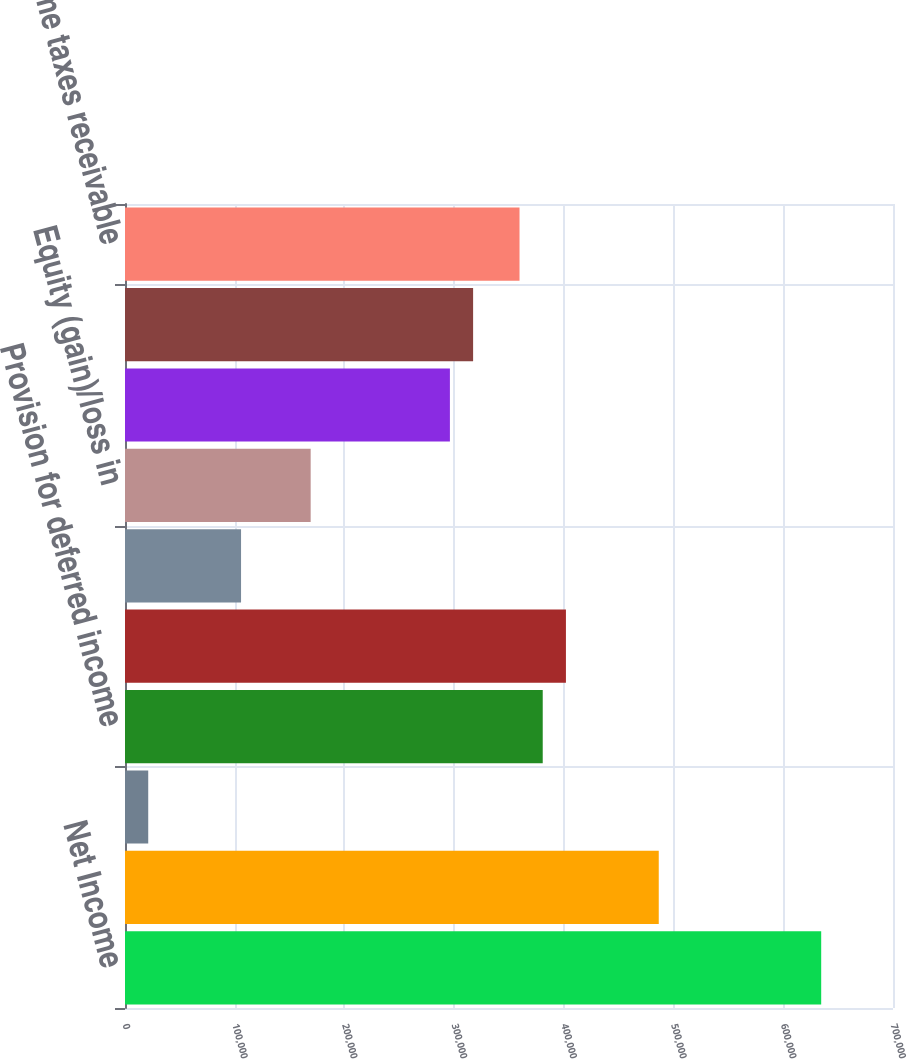Convert chart. <chart><loc_0><loc_0><loc_500><loc_500><bar_chart><fcel>Net Income<fcel>Depreciation and amortization<fcel>Other amortization<fcel>Provision for deferred income<fcel>Stock-based compensation<fcel>Loss on disposition of<fcel>Equity (gain)/loss in<fcel>Accounts receivable<fcel>Marketing fee receivable<fcel>Income taxes receivable<nl><fcel>634555<fcel>486497<fcel>21170.2<fcel>380741<fcel>401892<fcel>105775<fcel>169229<fcel>296136<fcel>317287<fcel>359589<nl></chart> 